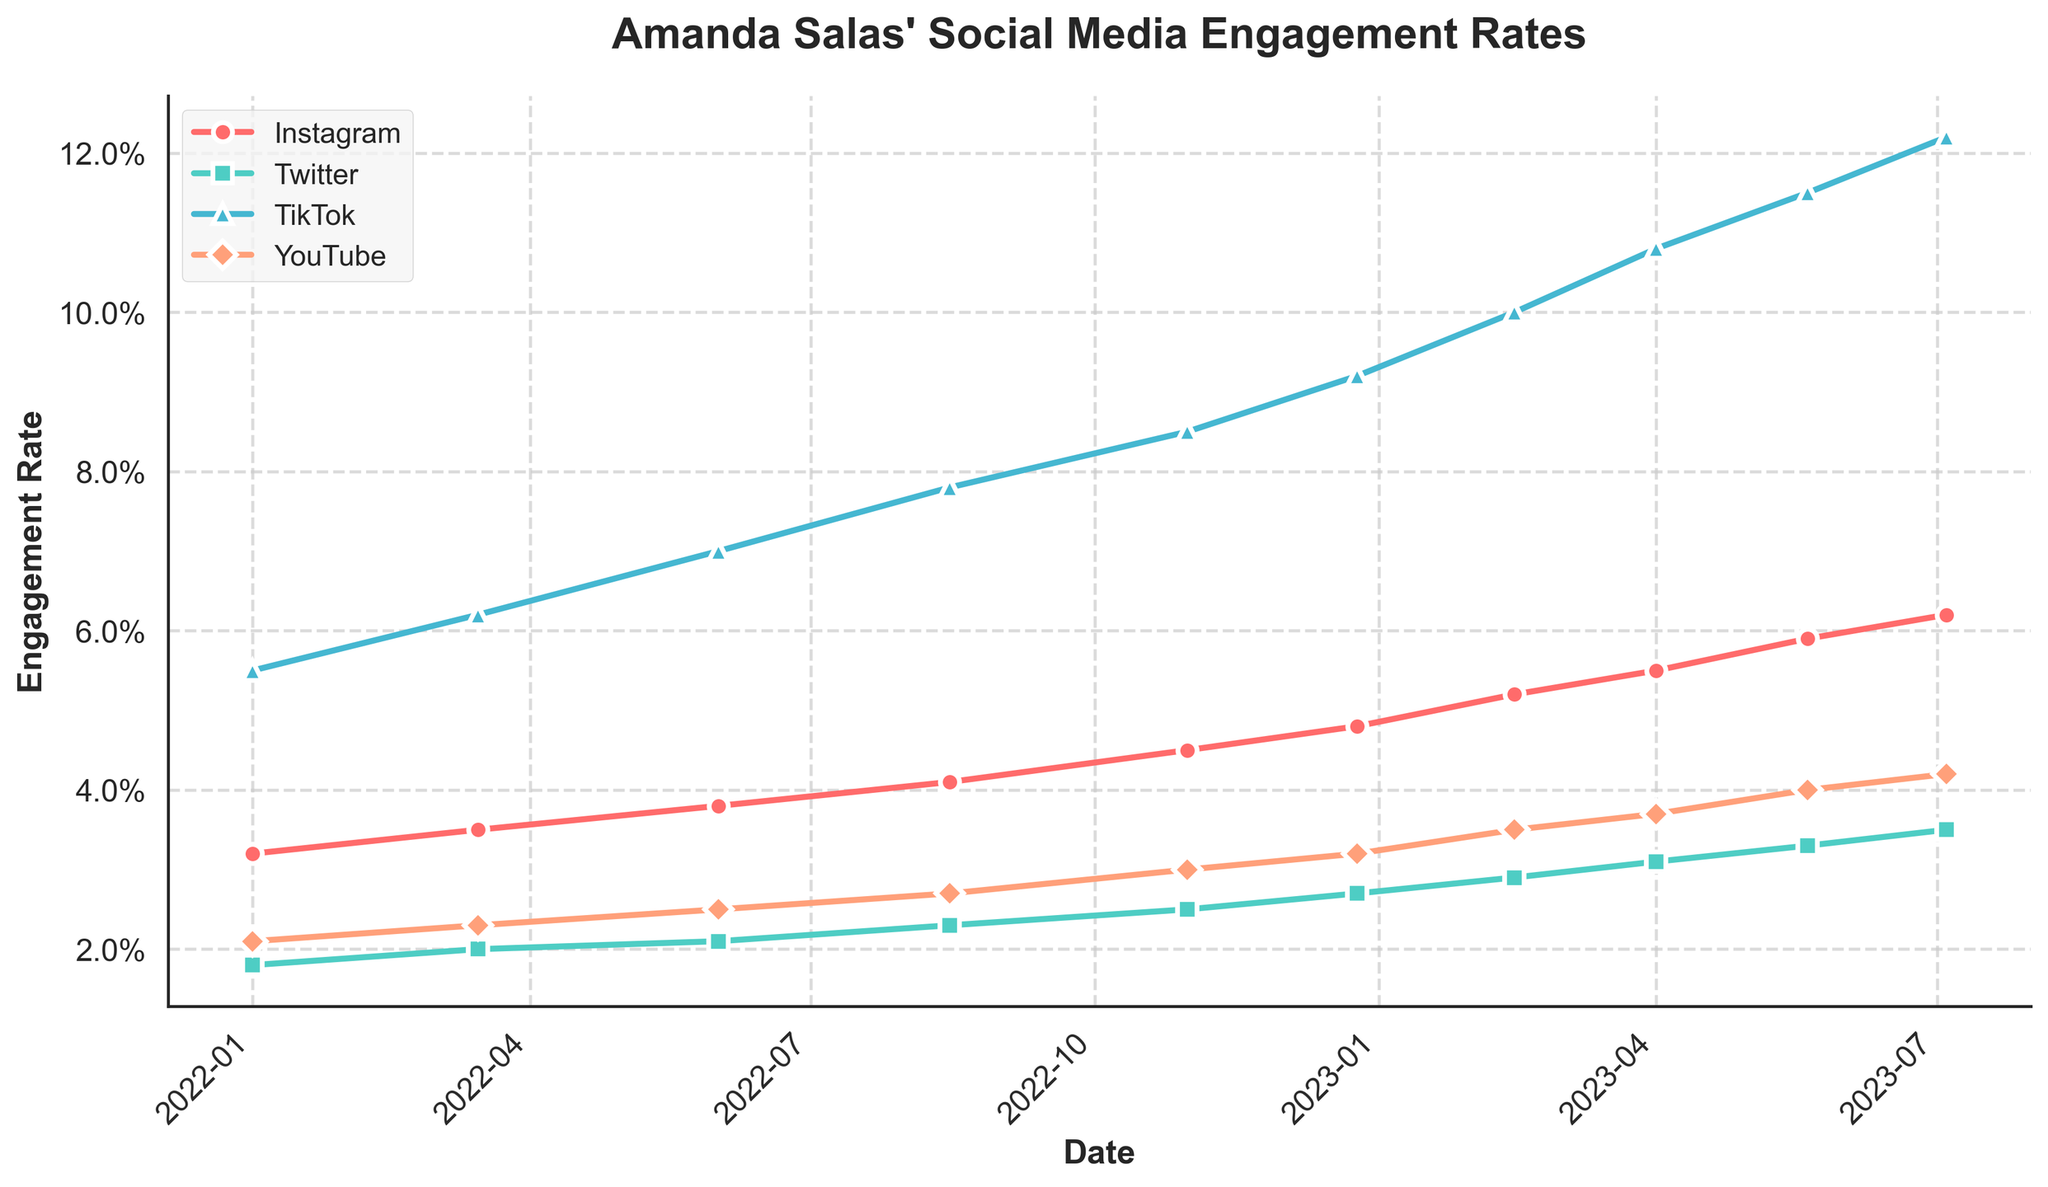Which platform had the highest engagement rate on 2022-01-01? Look at the data points for January 1, 2022, and identify the highest value. TikTok has the highest engagement rate at 5.5%.
Answer: TikTok How did Instagram's engagement rate change from 2022-01-01 to 2023-07-04? Subtract the engagement rate on 2022-01-01 (3.2%) from the engagement rate on 2023-07-04 (6.2%). The change is 6.2% - 3.2% = 3.0%.
Answer: Increased by 3.0% Which platform showed the steepest increase in engagement rate over the given period? By comparing the overall trends visually, TikTok's line shows the steepest increase from 5.5% to 12.2%.
Answer: TikTok On which date did YouTube's engagement rate surpass 3%? Look at the progression of YouTube's engagement rates and identify the first date it exceeds 3%. It's on 2022-10-31.
Answer: 2022-10-31 Did Twitter's engagement rate ever surpass 4%? Check all the data points for Twitter's engagement rate to see if any value is above 4%. All values are below 4%.
Answer: No Compare the engagement rate trends of Instagram and TikTok. Which platform had a higher growth rate? Calculate the initial and final engagement rates for both platforms. Instagram grew from 3.2% to 6.2%, an increase of 3.0%. TikTok grew from 5.5% to 12.2%, an increase of 6.7%. TikTok had a higher growth rate.
Answer: TikTok What is the average engagement rate of YouTube over the given period? Sum up all engagement rates of YouTube and then divide by the number of data points. (2.1% + 2.3% + 2.5% + 2.7% + 3.0% + 3.2% + 3.5% + 3.7% + 4.0% + 4.2%) / 10 = 3.12%.
Answer: 3.12% Between which dates did Twitter see its largest increase in engagement rate? Identify the period with the largest difference in engagement rates by subtracting each data point from the previous value. The largest increase is between 2022-12-25 (2.7%) and 2023-02-14 (2.9%), an increase of 0.2%.
Answer: 2022-12-25 to 2023-02-14 Which period saw a continuous increase in engagement rates for all platforms? Visually scan the periods and identify where all lines are continuously increasing. The period from 2022-01-01 to 2023-07-04 shows a continuous increase for all platforms.
Answer: 2022-01-01 to 2023-07-04 